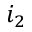<formula> <loc_0><loc_0><loc_500><loc_500>i _ { 2 }</formula> 